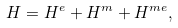Convert formula to latex. <formula><loc_0><loc_0><loc_500><loc_500>H = H ^ { e } + H ^ { m } + H ^ { m e } ,</formula> 